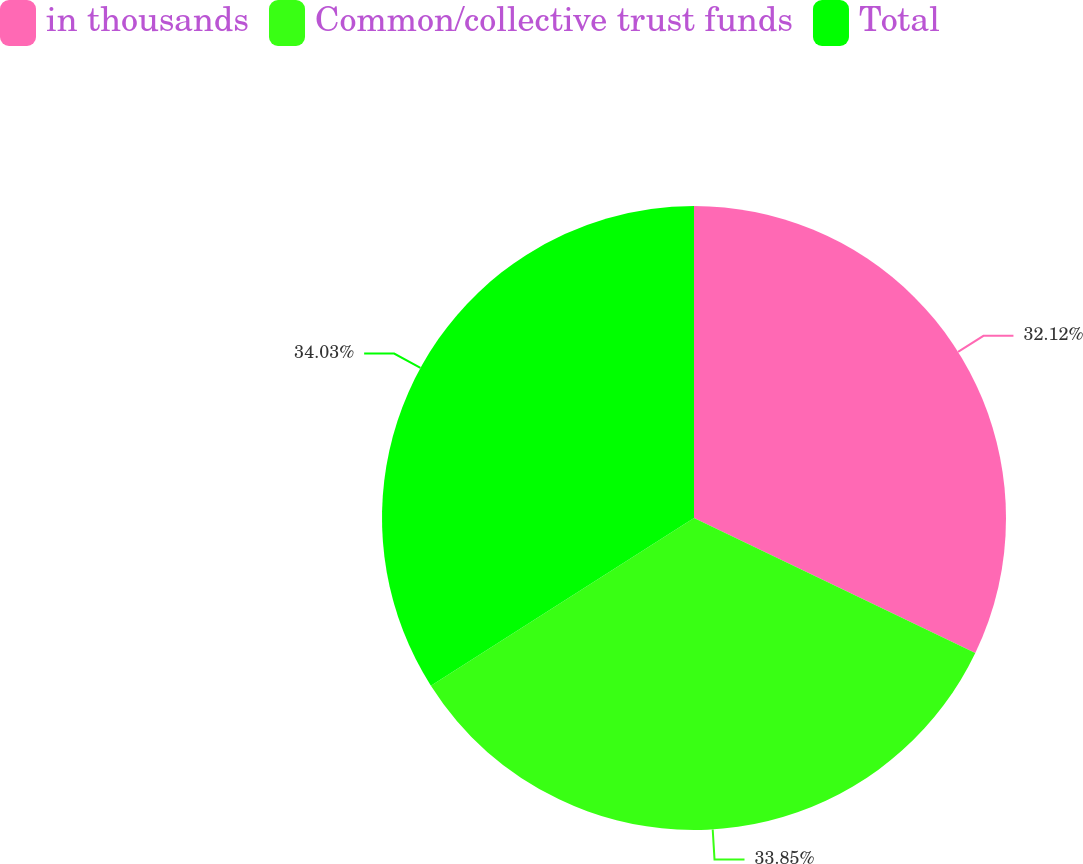Convert chart. <chart><loc_0><loc_0><loc_500><loc_500><pie_chart><fcel>in thousands<fcel>Common/collective trust funds<fcel>Total<nl><fcel>32.12%<fcel>33.85%<fcel>34.03%<nl></chart> 